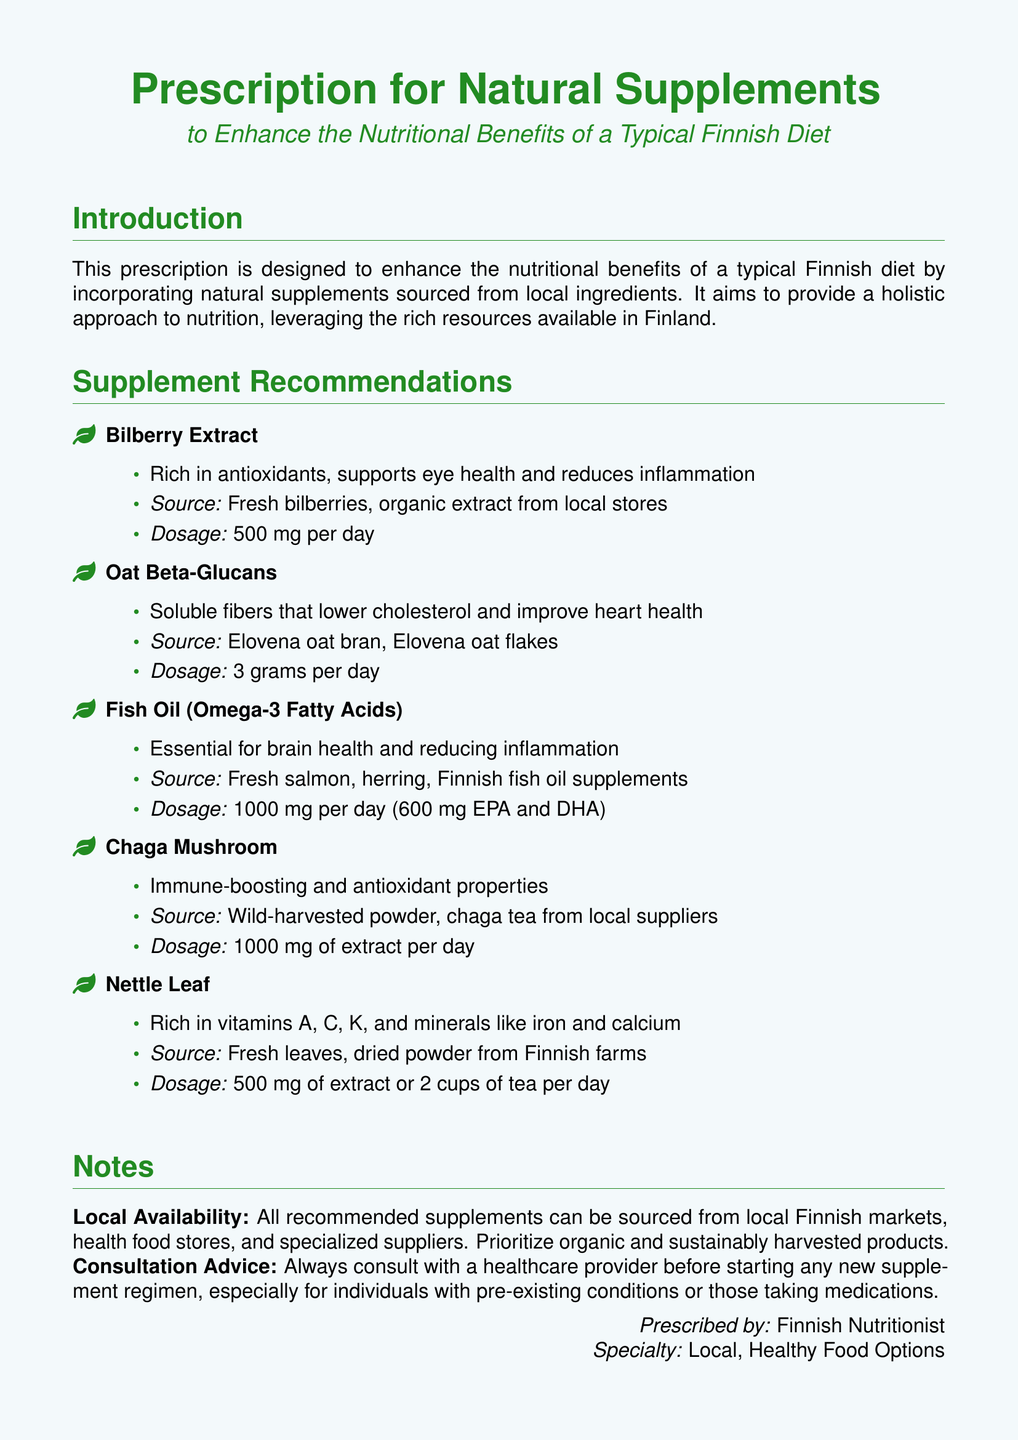What is the dosage for Bilberry Extract? The document specifies that the dosage for Bilberry Extract is 500 mg per day.
Answer: 500 mg per day What is the source of Oat Beta-Glucans? The source mentioned for Oat Beta-Glucans is Elovena oat bran and Elovena oat flakes.
Answer: Elovena oat bran, Elovena oat flakes How much Fish Oil should be taken daily? The document states that the recommended dosage for Fish Oil is 1000 mg per day.
Answer: 1000 mg per day What properties are associated with Chaga Mushroom? Chaga Mushroom is noted for having immune-boosting and antioxidant properties.
Answer: Immune-boosting and antioxidant properties What vitamins are found in Nettle Leaf? The vitamins mentioned for Nettle Leaf include A, C, and K.
Answer: A, C, K What is the document's title? The title of the document is "Prescription for Natural Supplements."
Answer: Prescription for Natural Supplements How is the document aimed at enhancing nutritional benefits? The document aims to enhance nutritional benefits by incorporating natural supplements sourced from local ingredients.
Answer: Incorporating natural supplements sourced from local ingredients What is advised before starting a new supplement regimen? The document advises to always consult with a healthcare provider.
Answer: Consult with a healthcare provider Where can the recommended supplements be sourced from? The document notes that the recommended supplements can be sourced from local Finnish markets, health food stores, and specialized suppliers.
Answer: Local Finnish markets, health food stores, and specialized suppliers 